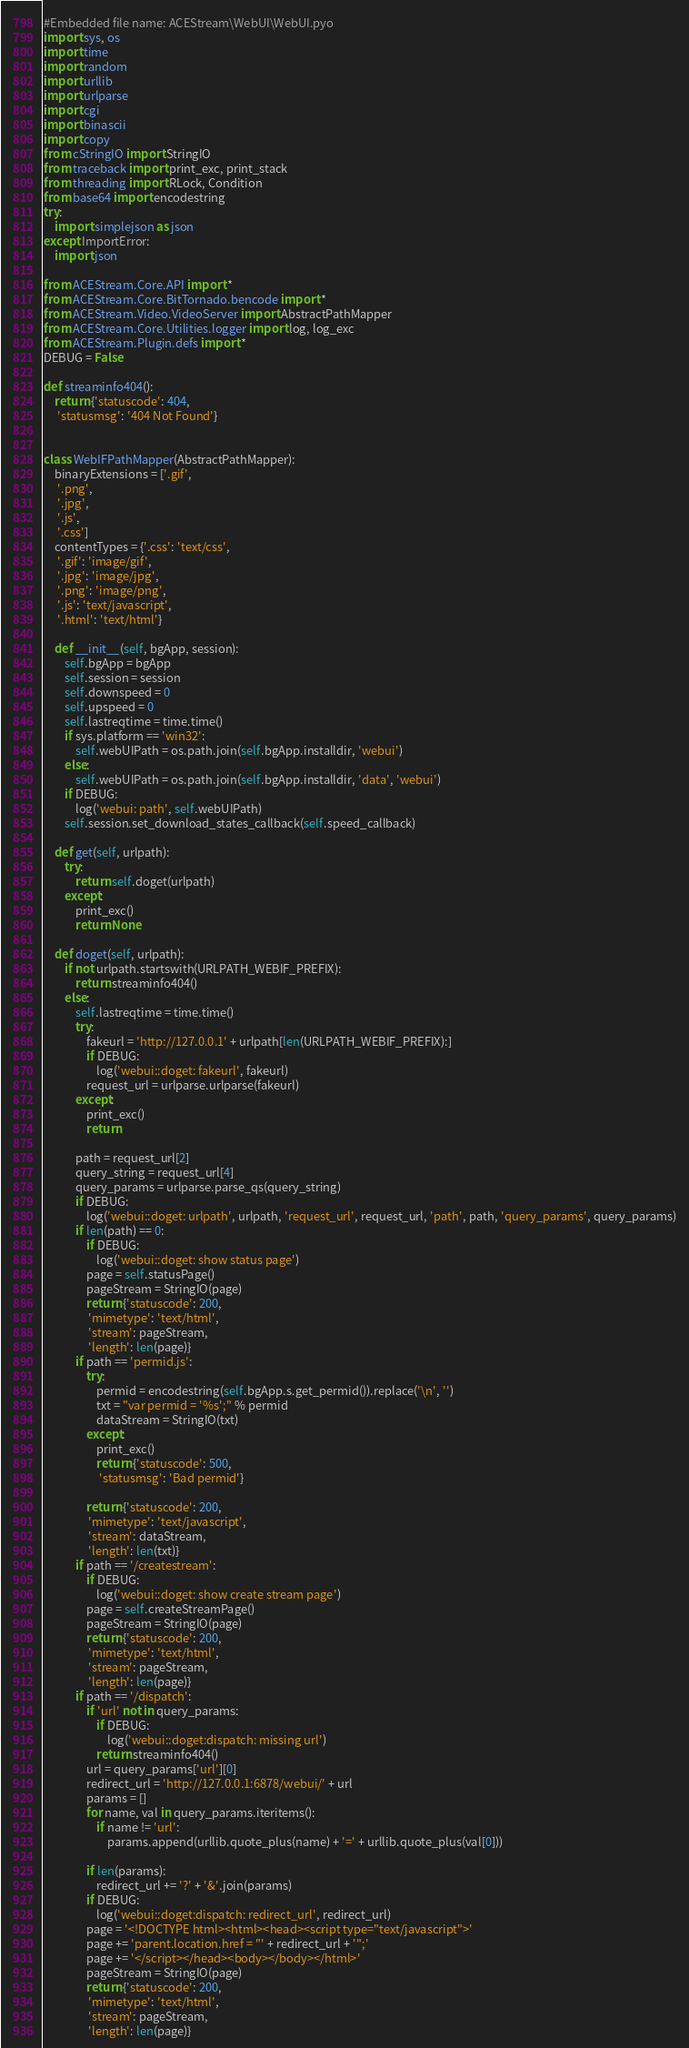<code> <loc_0><loc_0><loc_500><loc_500><_Python_>#Embedded file name: ACEStream\WebUI\WebUI.pyo
import sys, os
import time
import random
import urllib
import urlparse
import cgi
import binascii
import copy
from cStringIO import StringIO
from traceback import print_exc, print_stack
from threading import RLock, Condition
from base64 import encodestring
try:
    import simplejson as json
except ImportError:
    import json

from ACEStream.Core.API import *
from ACEStream.Core.BitTornado.bencode import *
from ACEStream.Video.VideoServer import AbstractPathMapper
from ACEStream.Core.Utilities.logger import log, log_exc
from ACEStream.Plugin.defs import *
DEBUG = False

def streaminfo404():
    return {'statuscode': 404,
     'statusmsg': '404 Not Found'}


class WebIFPathMapper(AbstractPathMapper):
    binaryExtensions = ['.gif',
     '.png',
     '.jpg',
     '.js',
     '.css']
    contentTypes = {'.css': 'text/css',
     '.gif': 'image/gif',
     '.jpg': 'image/jpg',
     '.png': 'image/png',
     '.js': 'text/javascript',
     '.html': 'text/html'}

    def __init__(self, bgApp, session):
        self.bgApp = bgApp
        self.session = session
        self.downspeed = 0
        self.upspeed = 0
        self.lastreqtime = time.time()
        if sys.platform == 'win32':
            self.webUIPath = os.path.join(self.bgApp.installdir, 'webui')
        else:
            self.webUIPath = os.path.join(self.bgApp.installdir, 'data', 'webui')
        if DEBUG:
            log('webui: path', self.webUIPath)
        self.session.set_download_states_callback(self.speed_callback)

    def get(self, urlpath):
        try:
            return self.doget(urlpath)
        except:
            print_exc()
            return None

    def doget(self, urlpath):
        if not urlpath.startswith(URLPATH_WEBIF_PREFIX):
            return streaminfo404()
        else:
            self.lastreqtime = time.time()
            try:
                fakeurl = 'http://127.0.0.1' + urlpath[len(URLPATH_WEBIF_PREFIX):]
                if DEBUG:
                    log('webui::doget: fakeurl', fakeurl)
                request_url = urlparse.urlparse(fakeurl)
            except:
                print_exc()
                return

            path = request_url[2]
            query_string = request_url[4]
            query_params = urlparse.parse_qs(query_string)
            if DEBUG:
                log('webui::doget: urlpath', urlpath, 'request_url', request_url, 'path', path, 'query_params', query_params)
            if len(path) == 0:
                if DEBUG:
                    log('webui::doget: show status page')
                page = self.statusPage()
                pageStream = StringIO(page)
                return {'statuscode': 200,
                 'mimetype': 'text/html',
                 'stream': pageStream,
                 'length': len(page)}
            if path == 'permid.js':
                try:
                    permid = encodestring(self.bgApp.s.get_permid()).replace('\n', '')
                    txt = "var permid = '%s';" % permid
                    dataStream = StringIO(txt)
                except:
                    print_exc()
                    return {'statuscode': 500,
                     'statusmsg': 'Bad permid'}

                return {'statuscode': 200,
                 'mimetype': 'text/javascript',
                 'stream': dataStream,
                 'length': len(txt)}
            if path == '/createstream':
                if DEBUG:
                    log('webui::doget: show create stream page')
                page = self.createStreamPage()
                pageStream = StringIO(page)
                return {'statuscode': 200,
                 'mimetype': 'text/html',
                 'stream': pageStream,
                 'length': len(page)}
            if path == '/dispatch':
                if 'url' not in query_params:
                    if DEBUG:
                        log('webui::doget:dispatch: missing url')
                    return streaminfo404()
                url = query_params['url'][0]
                redirect_url = 'http://127.0.0.1:6878/webui/' + url
                params = []
                for name, val in query_params.iteritems():
                    if name != 'url':
                        params.append(urllib.quote_plus(name) + '=' + urllib.quote_plus(val[0]))

                if len(params):
                    redirect_url += '?' + '&'.join(params)
                if DEBUG:
                    log('webui::doget:dispatch: redirect_url', redirect_url)
                page = '<!DOCTYPE html><html><head><script type="text/javascript">'
                page += 'parent.location.href = "' + redirect_url + '";'
                page += '</script></head><body></body></html>'
                pageStream = StringIO(page)
                return {'statuscode': 200,
                 'mimetype': 'text/html',
                 'stream': pageStream,
                 'length': len(page)}</code> 